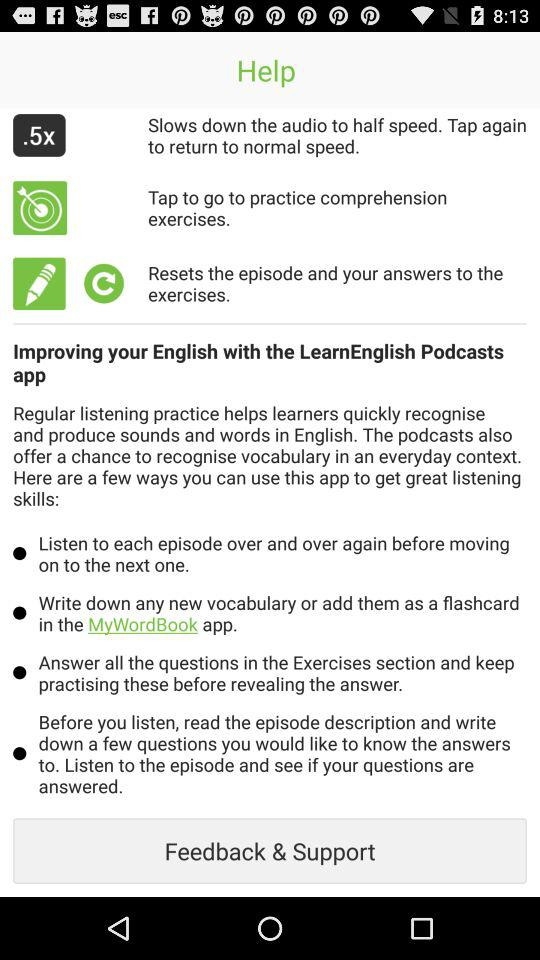What application is mentioned? The mentioned application is "MyWordBook". 